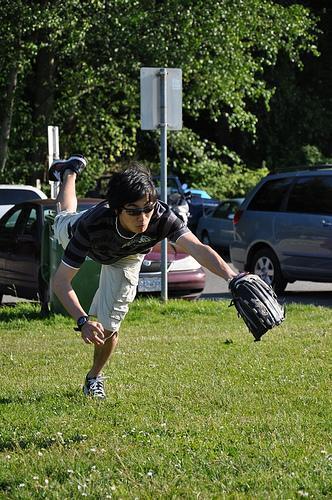How many people are in the picture?
Give a very brief answer. 1. How many people are there?
Give a very brief answer. 1. How many cars are there?
Give a very brief answer. 2. 